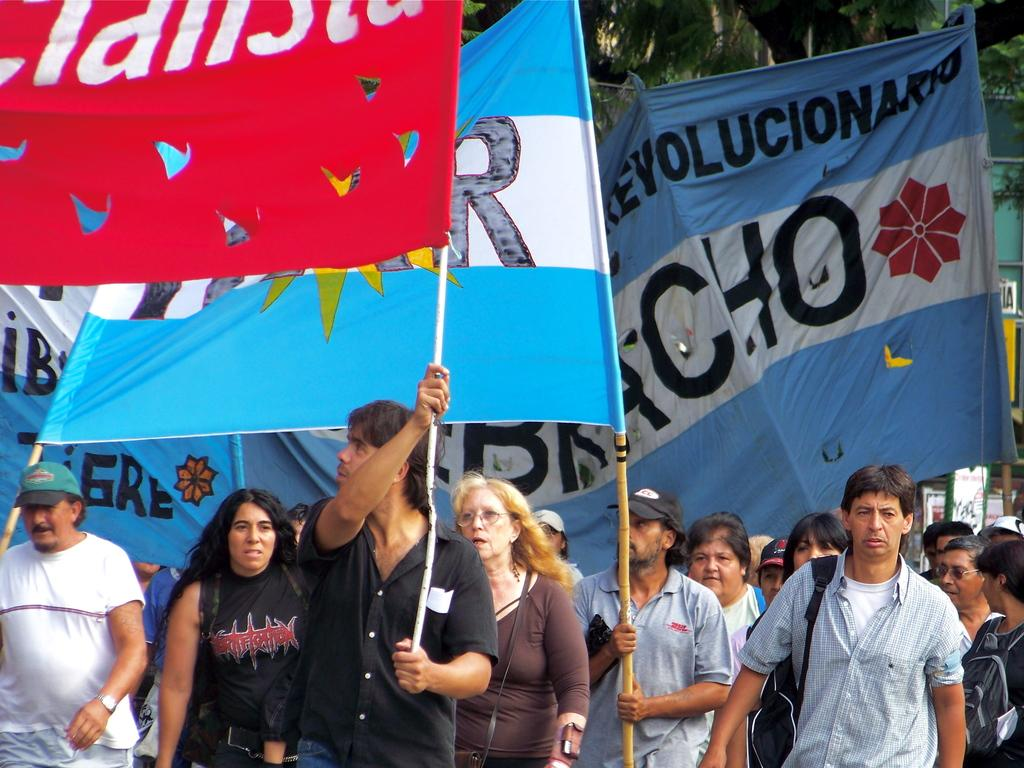<image>
Provide a brief description of the given image. Many protesters are holding banners, including one wearing a DHL shirt. 